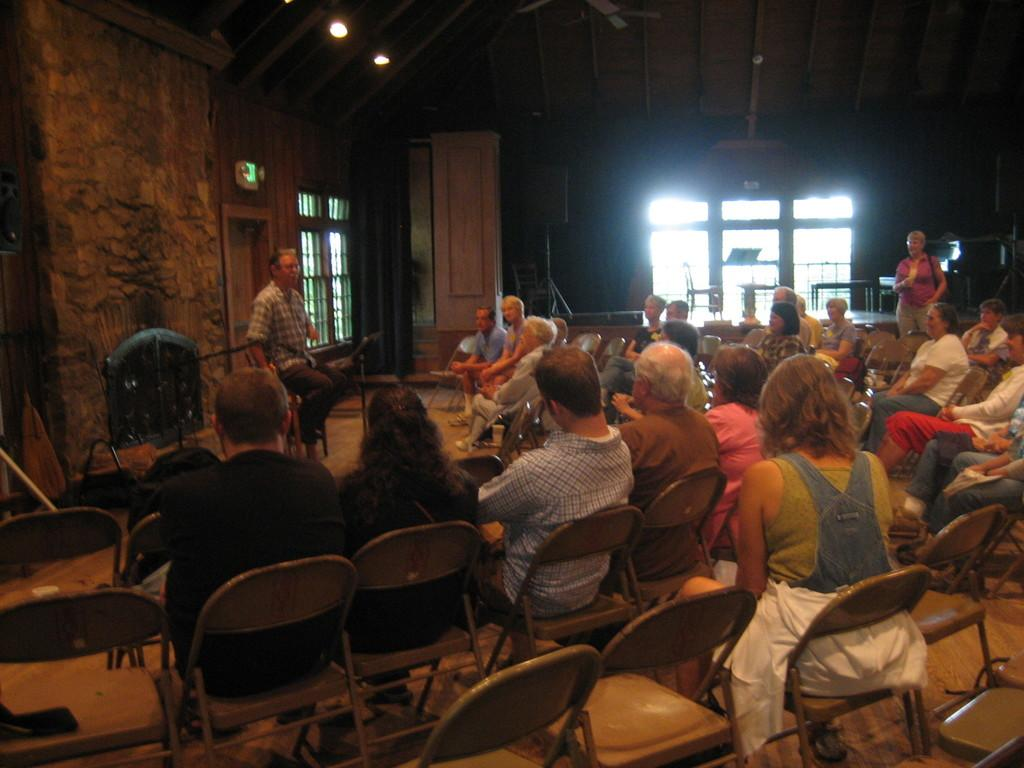What type of openings can be seen in the image? There are windows in the image. What type of furniture is present in the image? There are chairs and tables in the image. What device is visible in the image? There is a speaker in the image. How many people are in the image? There are people in the image, and one person is standing. What else can be seen in the image besides the people and furniture? There are objects in the image. Can you see any quills being used by the people in the image? There is no mention of quills in the image, so it cannot be determined if they are being used. Is the sea visible in the image? The image does not show any sea or water bodies; it contains windows, chairs, tables, a speaker, and people. 